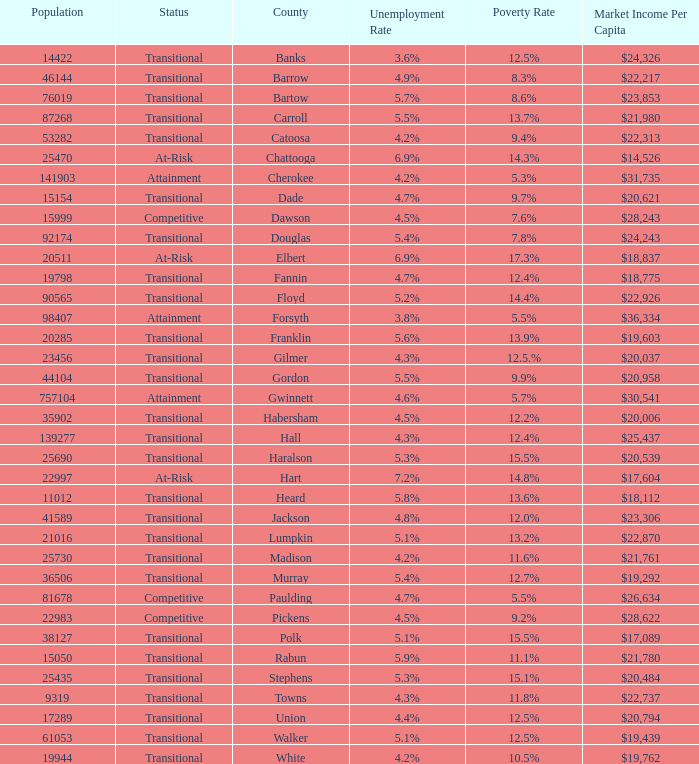What is the status of the county with per capita market income of $24,326? Transitional. I'm looking to parse the entire table for insights. Could you assist me with that? {'header': ['Population', 'Status', 'County', 'Unemployment Rate', 'Poverty Rate', 'Market Income Per Capita'], 'rows': [['14422', 'Transitional', 'Banks', '3.6%', '12.5%', '$24,326'], ['46144', 'Transitional', 'Barrow', '4.9%', '8.3%', '$22,217'], ['76019', 'Transitional', 'Bartow', '5.7%', '8.6%', '$23,853'], ['87268', 'Transitional', 'Carroll', '5.5%', '13.7%', '$21,980'], ['53282', 'Transitional', 'Catoosa', '4.2%', '9.4%', '$22,313'], ['25470', 'At-Risk', 'Chattooga', '6.9%', '14.3%', '$14,526'], ['141903', 'Attainment', 'Cherokee', '4.2%', '5.3%', '$31,735'], ['15154', 'Transitional', 'Dade', '4.7%', '9.7%', '$20,621'], ['15999', 'Competitive', 'Dawson', '4.5%', '7.6%', '$28,243'], ['92174', 'Transitional', 'Douglas', '5.4%', '7.8%', '$24,243'], ['20511', 'At-Risk', 'Elbert', '6.9%', '17.3%', '$18,837'], ['19798', 'Transitional', 'Fannin', '4.7%', '12.4%', '$18,775'], ['90565', 'Transitional', 'Floyd', '5.2%', '14.4%', '$22,926'], ['98407', 'Attainment', 'Forsyth', '3.8%', '5.5%', '$36,334'], ['20285', 'Transitional', 'Franklin', '5.6%', '13.9%', '$19,603'], ['23456', 'Transitional', 'Gilmer', '4.3%', '12.5.%', '$20,037'], ['44104', 'Transitional', 'Gordon', '5.5%', '9.9%', '$20,958'], ['757104', 'Attainment', 'Gwinnett', '4.6%', '5.7%', '$30,541'], ['35902', 'Transitional', 'Habersham', '4.5%', '12.2%', '$20,006'], ['139277', 'Transitional', 'Hall', '4.3%', '12.4%', '$25,437'], ['25690', 'Transitional', 'Haralson', '5.3%', '15.5%', '$20,539'], ['22997', 'At-Risk', 'Hart', '7.2%', '14.8%', '$17,604'], ['11012', 'Transitional', 'Heard', '5.8%', '13.6%', '$18,112'], ['41589', 'Transitional', 'Jackson', '4.8%', '12.0%', '$23,306'], ['21016', 'Transitional', 'Lumpkin', '5.1%', '13.2%', '$22,870'], ['25730', 'Transitional', 'Madison', '4.2%', '11.6%', '$21,761'], ['36506', 'Transitional', 'Murray', '5.4%', '12.7%', '$19,292'], ['81678', 'Competitive', 'Paulding', '4.7%', '5.5%', '$26,634'], ['22983', 'Competitive', 'Pickens', '4.5%', '9.2%', '$28,622'], ['38127', 'Transitional', 'Polk', '5.1%', '15.5%', '$17,089'], ['15050', 'Transitional', 'Rabun', '5.9%', '11.1%', '$21,780'], ['25435', 'Transitional', 'Stephens', '5.3%', '15.1%', '$20,484'], ['9319', 'Transitional', 'Towns', '4.3%', '11.8%', '$22,737'], ['17289', 'Transitional', 'Union', '4.4%', '12.5%', '$20,794'], ['61053', 'Transitional', 'Walker', '5.1%', '12.5%', '$19,439'], ['19944', 'Transitional', 'White', '4.2%', '10.5%', '$19,762']]} 